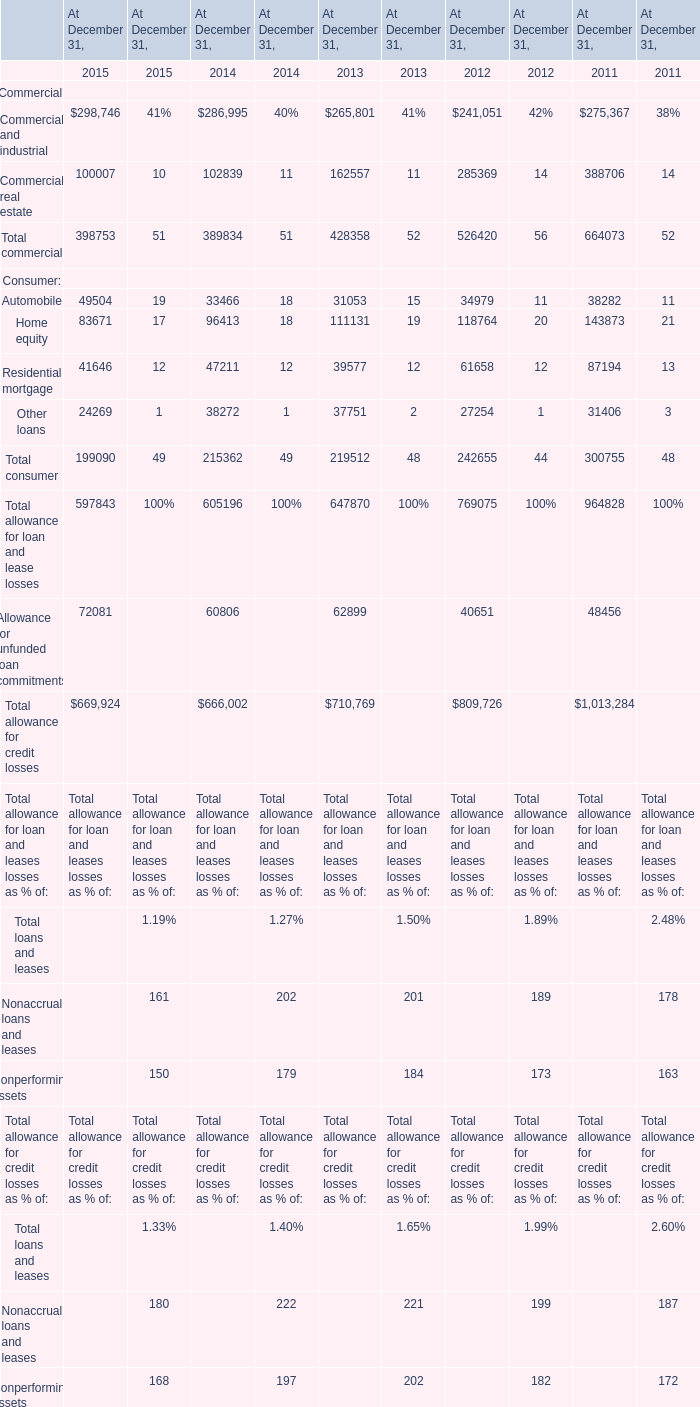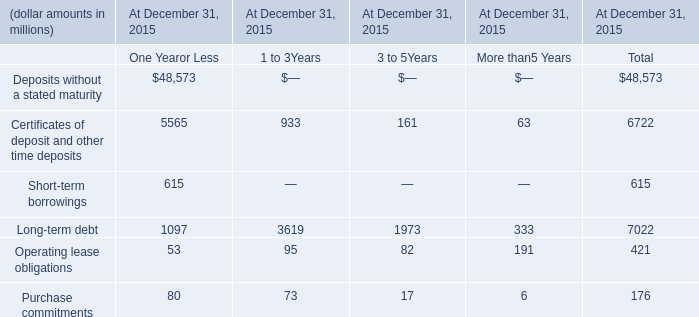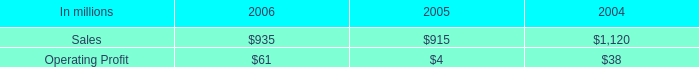in 2006 what percentage of specialty businesses sales are from arizona chemical sales? 
Computations: (769 / 935)
Answer: 0.82246. 